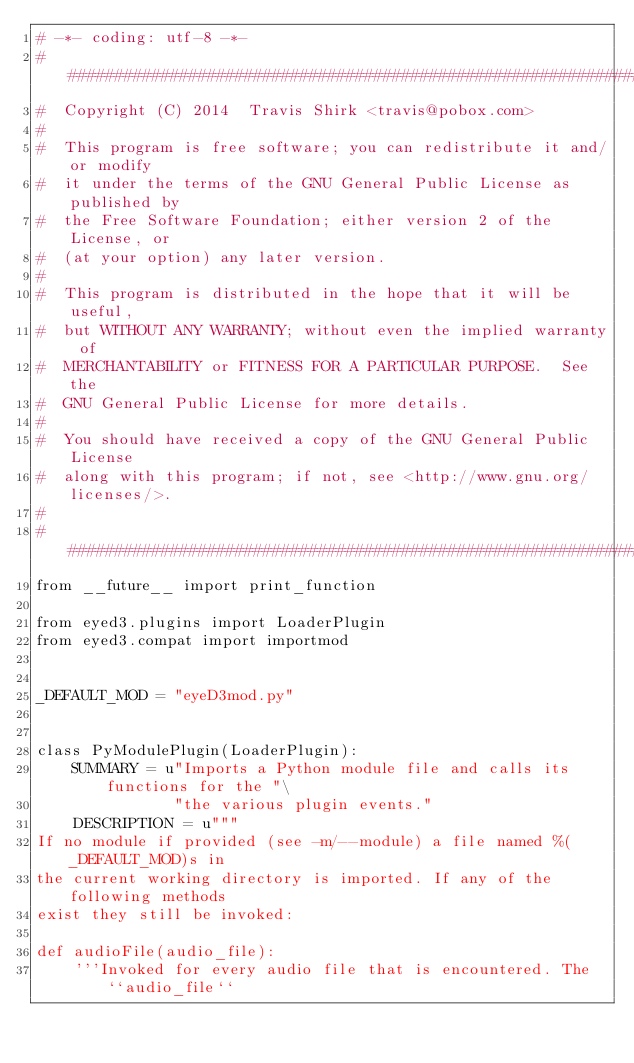<code> <loc_0><loc_0><loc_500><loc_500><_Python_># -*- coding: utf-8 -*-
################################################################################
#  Copyright (C) 2014  Travis Shirk <travis@pobox.com>
#
#  This program is free software; you can redistribute it and/or modify
#  it under the terms of the GNU General Public License as published by
#  the Free Software Foundation; either version 2 of the License, or
#  (at your option) any later version.
#
#  This program is distributed in the hope that it will be useful,
#  but WITHOUT ANY WARRANTY; without even the implied warranty of
#  MERCHANTABILITY or FITNESS FOR A PARTICULAR PURPOSE.  See the
#  GNU General Public License for more details.
#
#  You should have received a copy of the GNU General Public License
#  along with this program; if not, see <http://www.gnu.org/licenses/>.
#
################################################################################
from __future__ import print_function

from eyed3.plugins import LoaderPlugin
from eyed3.compat import importmod


_DEFAULT_MOD = "eyeD3mod.py"


class PyModulePlugin(LoaderPlugin):
    SUMMARY = u"Imports a Python module file and calls its functions for the "\
               "the various plugin events."
    DESCRIPTION = u"""
If no module if provided (see -m/--module) a file named %(_DEFAULT_MOD)s in
the current working directory is imported. If any of the following methods
exist they still be invoked:

def audioFile(audio_file):
    '''Invoked for every audio file that is encountered. The ``audio_file``</code> 